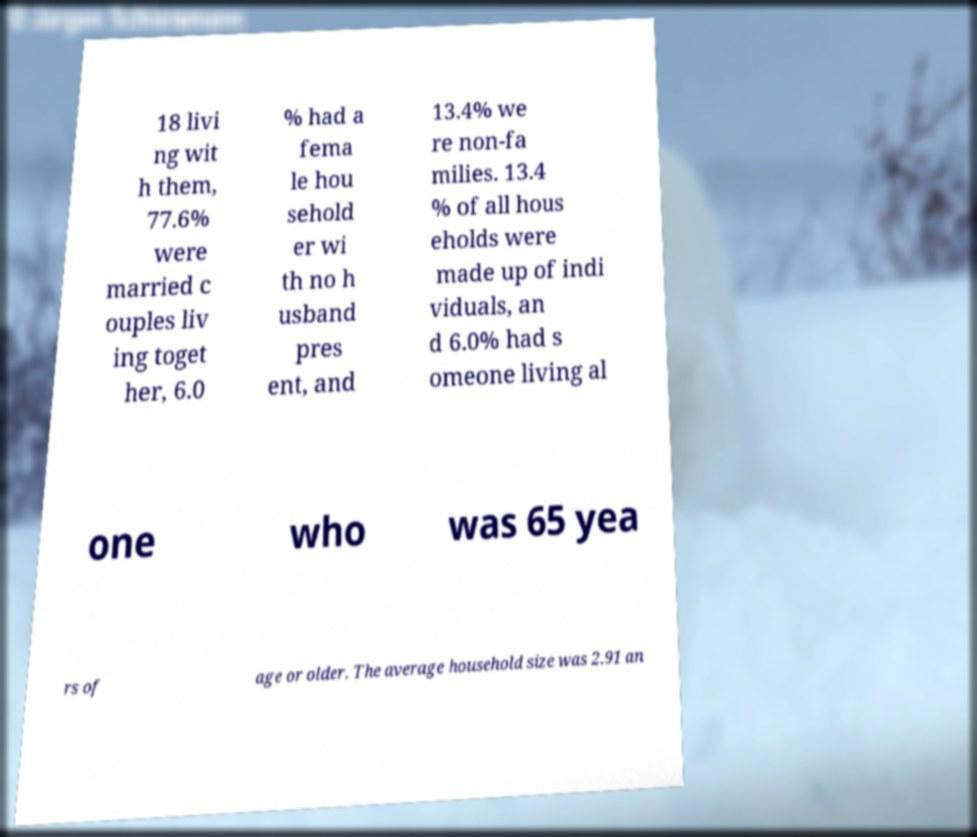Could you extract and type out the text from this image? 18 livi ng wit h them, 77.6% were married c ouples liv ing toget her, 6.0 % had a fema le hou sehold er wi th no h usband pres ent, and 13.4% we re non-fa milies. 13.4 % of all hous eholds were made up of indi viduals, an d 6.0% had s omeone living al one who was 65 yea rs of age or older. The average household size was 2.91 an 